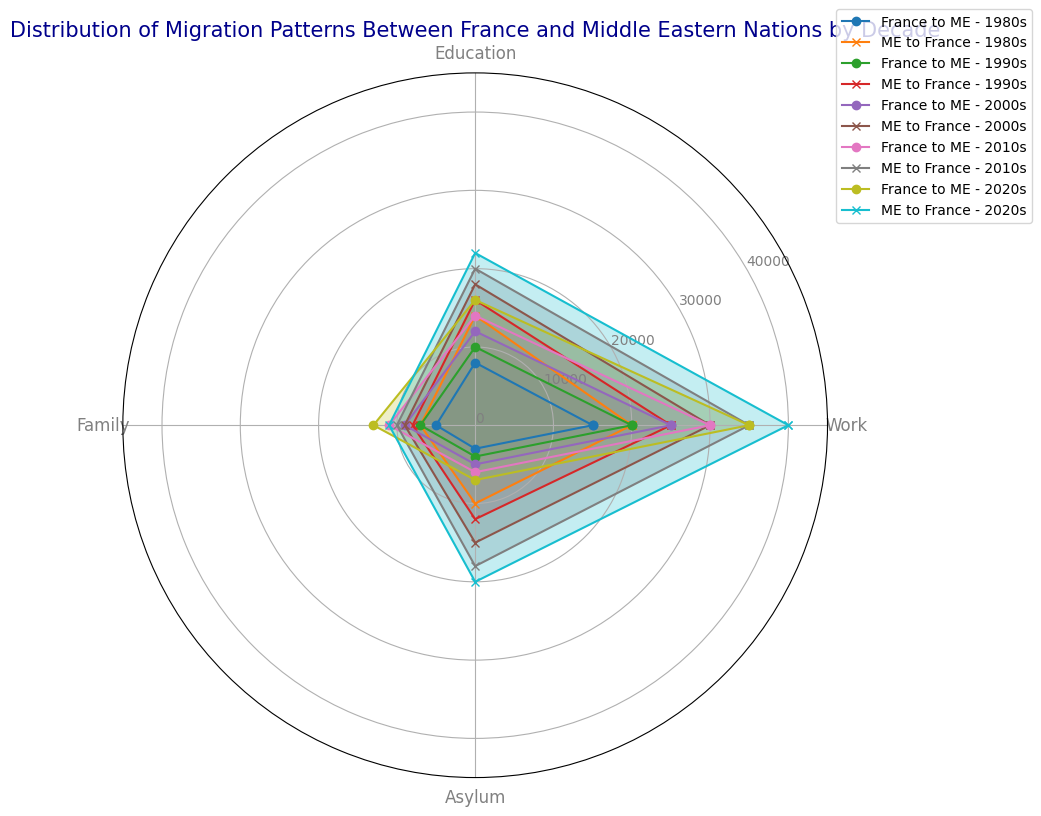What is the primary reason for migration from the Middle East to France in the 2010s? The radar chart shows that the largest category for migration from the Middle East to France in the 2010s is Asylum, as represented by the longest orange line extending toward the Asylum label.
Answer: Asylum Which decade saw the largest increase in migration for work from France to the Middle East? By comparing the lengths of the lines marking Work migration from France to the Middle East across decades, we see the largest increase between the 2010s and 2020s. The lengths increase from 30000 in the 2010s to 35000 in the 2020s.
Answer: 2020s What was the difference in migration due to Education between France to the Middle East and Middle East to France in the 2000s? In the 2000s, migration for Education from France to the Middle East was 12000, while from the Middle East to France it was 18000. The difference is calculated as 18000 - 12000 = 6000.
Answer: 6000 For which reason was migration equally frequent in the 2000s for both directions? The radar chart lines for Family in the 2000s for both France to Middle East and Middle East to France overlap and reach the same point on the scale, indicating both had 9000 migrants.
Answer: Family How many total migrants moved for Family reasons in the 1980s between France and the Middle East? Migration for Family reasons from France to the Middle East in the 1980s was 5000, and from the Middle East to France was 7000. Adding these totals: 5000 + 7000 = 12000.
Answer: 12000 Which had more migrants for Work in the 2020s: France to Middle East or Middle East to France? By how much? Comparing the lengths of the lines for Work migration, the Middle East to France is 40000, and France to the Middle East is 35000. The difference is 40000 - 35000 = 5000.
Answer: Middle East to France by 5000 In which decade did Family migration from the Middle East to France see no increase from the previous decade? By comparing each decade's Family migration values from the Middle East to France, we see that the values do not increase from the 2000s (9000) to the 2010s (10000) and from the 2010s (10000) to the 2020s (11000), meaning an increase of 0 from the 2000s to the 2010s.
Answer: 2000s to 2010s What is the average number of migrants for Asylum reasons between France and the Middle East in the 1990s? Adding the Asylum migration numbers between France and the Middle East in the 1990s: 4000 + 12000 = 16000. The average, therefore, is 16000 / 2 = 8000.
Answer: 8000 